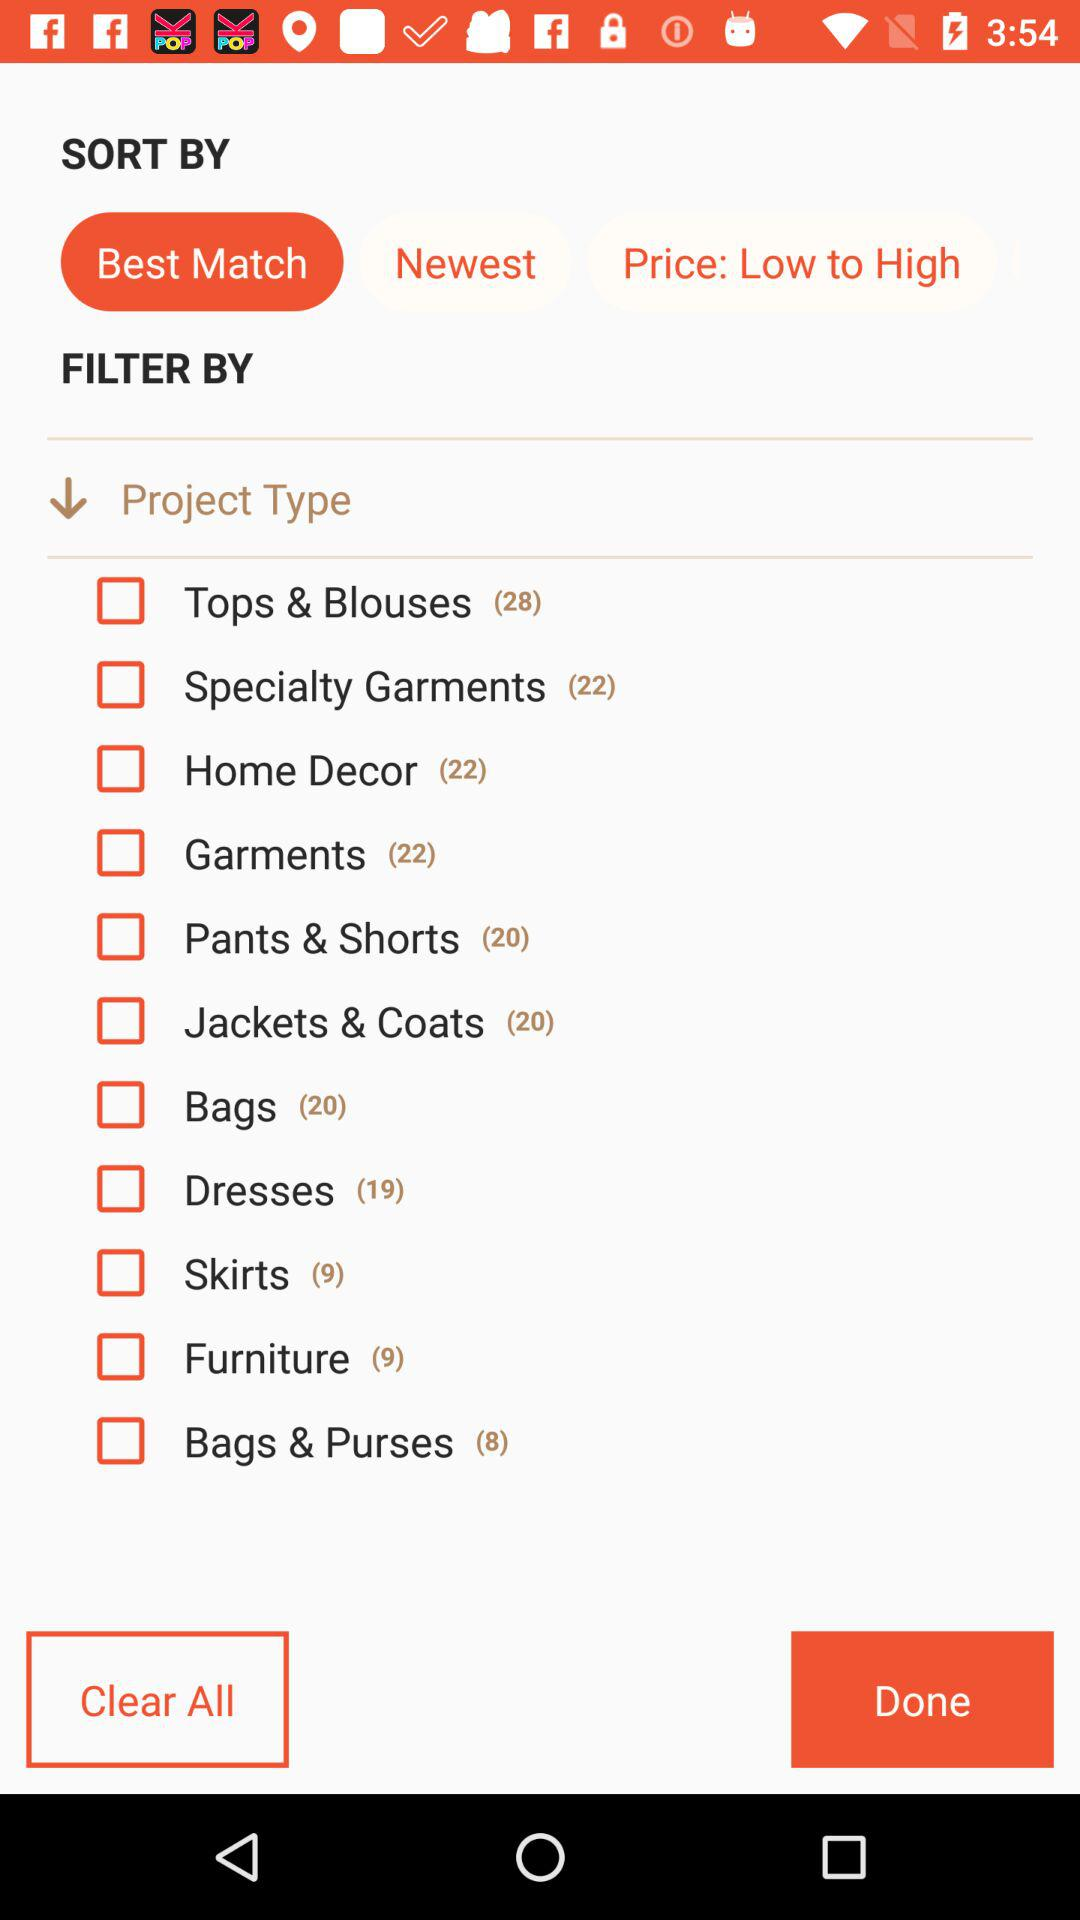How many varieties of furniture are there? There are 9 varieties of furniture. 